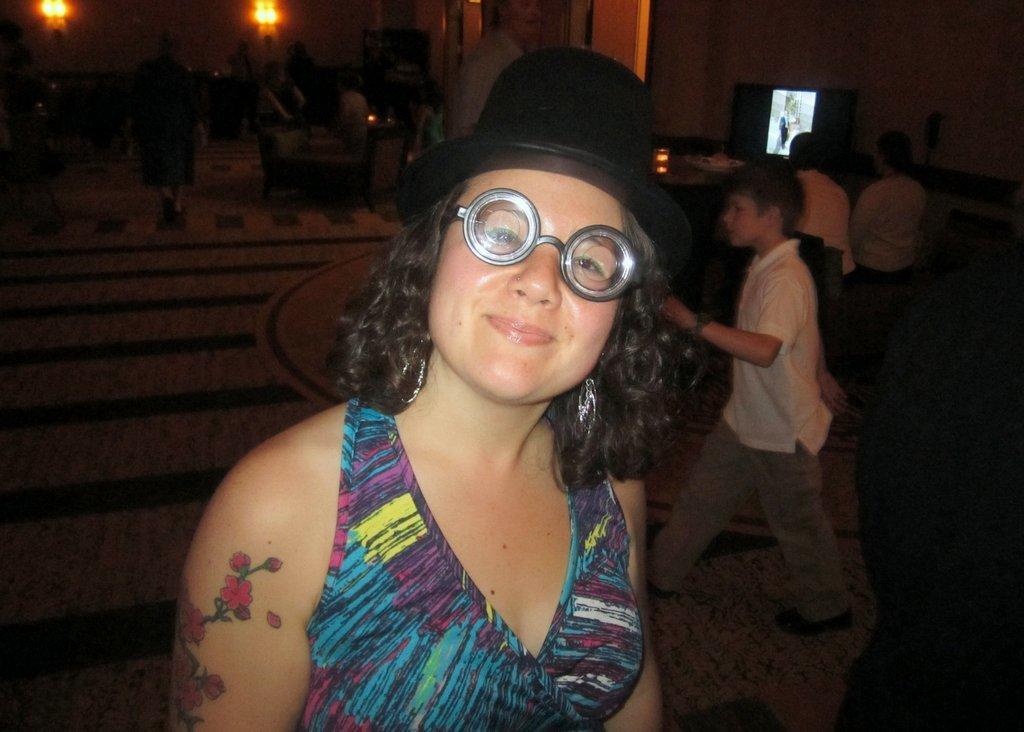Could you give a brief overview of what you see in this image? This image consists of some persons. There is a screen at the top. There is a person in the middle. She is a woman. She is wearing a hat and goggles. 